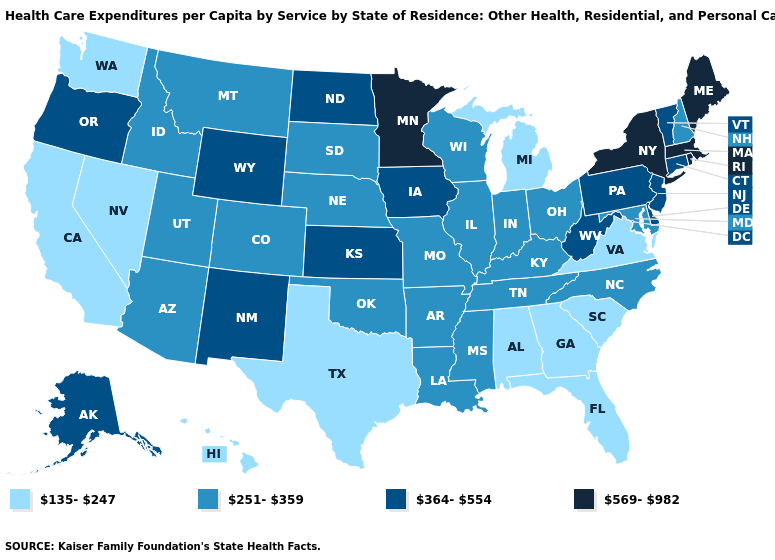What is the value of California?
Quick response, please. 135-247. Among the states that border Washington , which have the highest value?
Short answer required. Oregon. Name the states that have a value in the range 569-982?
Answer briefly. Maine, Massachusetts, Minnesota, New York, Rhode Island. What is the value of South Dakota?
Give a very brief answer. 251-359. What is the value of Louisiana?
Concise answer only. 251-359. What is the value of Illinois?
Answer briefly. 251-359. Does Texas have the lowest value in the USA?
Quick response, please. Yes. Name the states that have a value in the range 251-359?
Be succinct. Arizona, Arkansas, Colorado, Idaho, Illinois, Indiana, Kentucky, Louisiana, Maryland, Mississippi, Missouri, Montana, Nebraska, New Hampshire, North Carolina, Ohio, Oklahoma, South Dakota, Tennessee, Utah, Wisconsin. What is the value of Iowa?
Be succinct. 364-554. Name the states that have a value in the range 569-982?
Short answer required. Maine, Massachusetts, Minnesota, New York, Rhode Island. What is the value of New York?
Short answer required. 569-982. Name the states that have a value in the range 251-359?
Answer briefly. Arizona, Arkansas, Colorado, Idaho, Illinois, Indiana, Kentucky, Louisiana, Maryland, Mississippi, Missouri, Montana, Nebraska, New Hampshire, North Carolina, Ohio, Oklahoma, South Dakota, Tennessee, Utah, Wisconsin. Does New Jersey have a higher value than Montana?
Keep it brief. Yes. Does Colorado have a higher value than Oregon?
Keep it brief. No. Which states have the highest value in the USA?
Answer briefly. Maine, Massachusetts, Minnesota, New York, Rhode Island. 